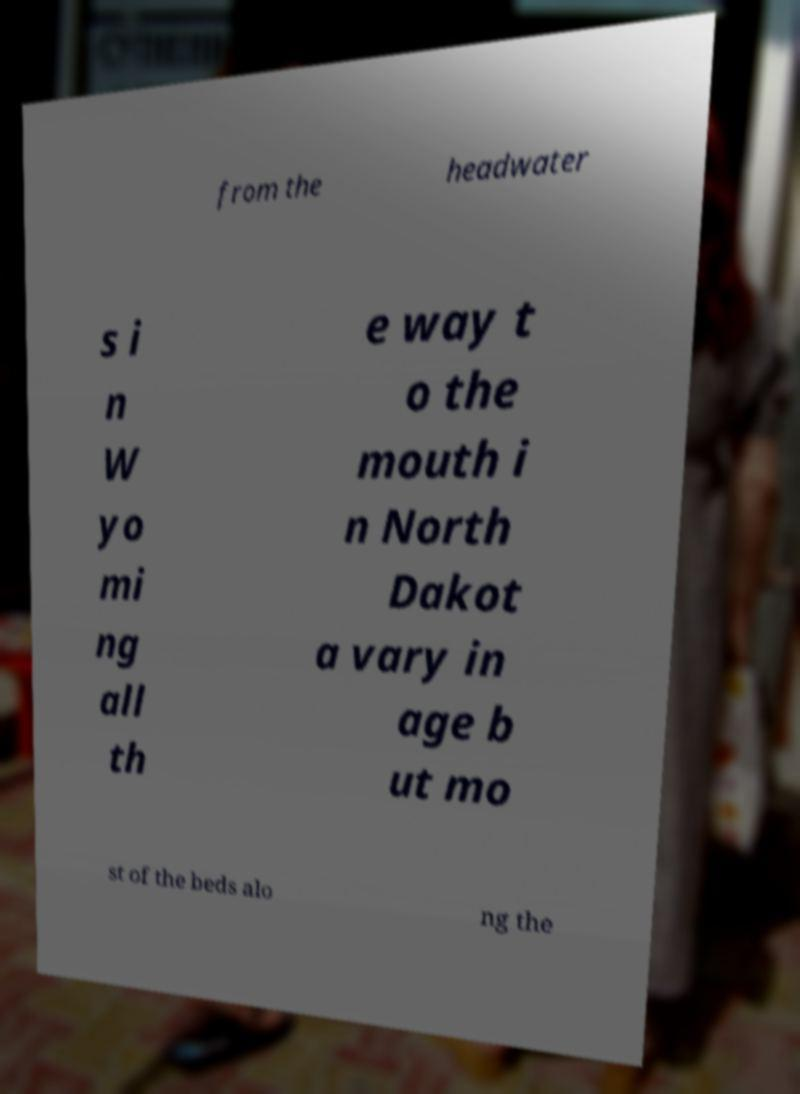I need the written content from this picture converted into text. Can you do that? from the headwater s i n W yo mi ng all th e way t o the mouth i n North Dakot a vary in age b ut mo st of the beds alo ng the 